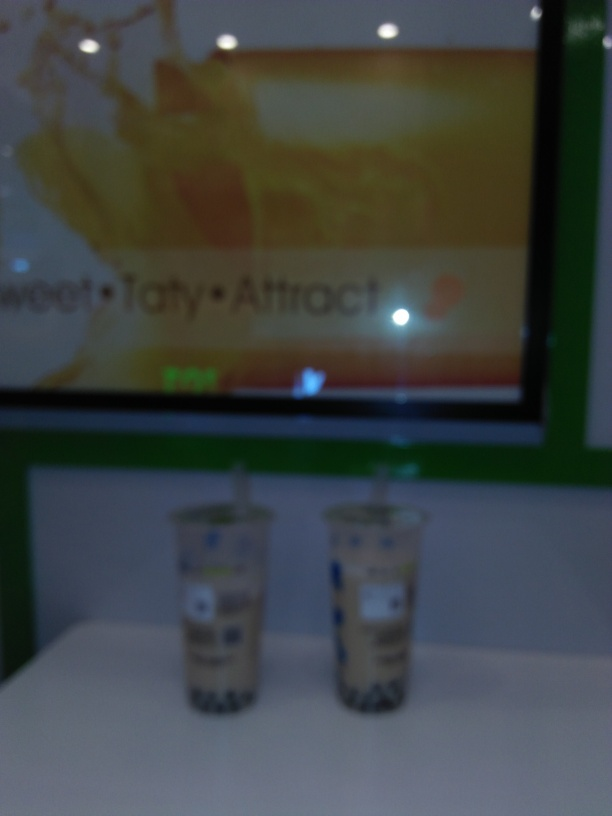Is there any branding or logos visible in the image? There are visible branding elements and logos, both on the cups and the advertisement background, though they are slightly blurry. The designs suggest that the image may have been taken at a commercial establishment that sells beverages. 